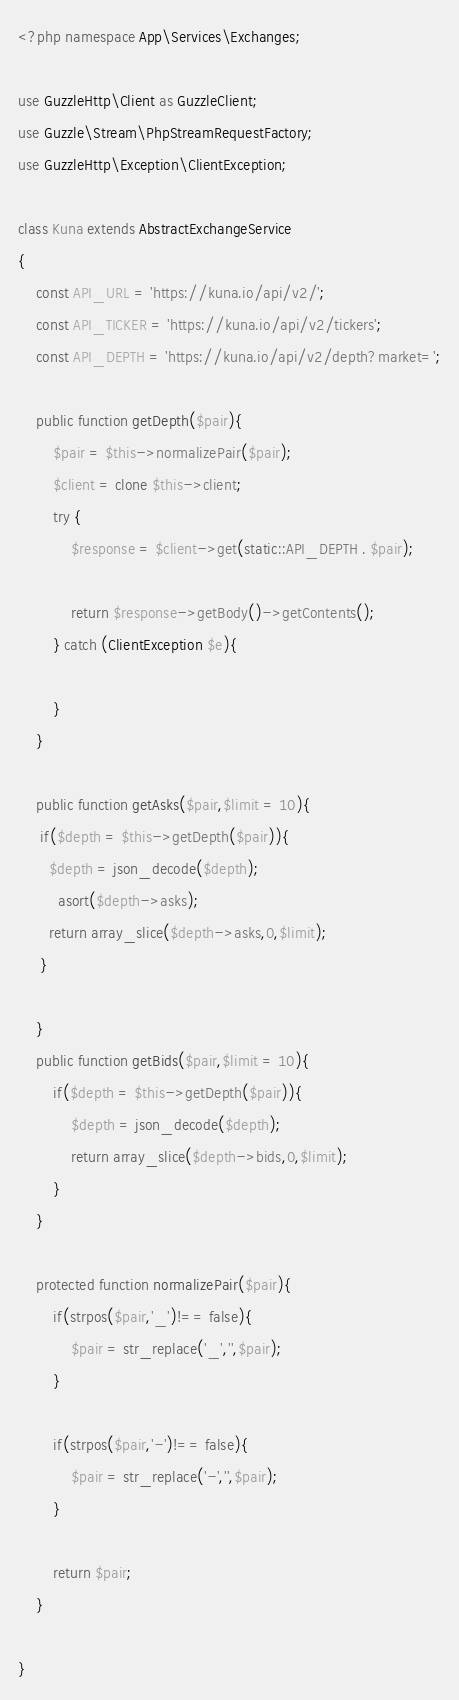Convert code to text. <code><loc_0><loc_0><loc_500><loc_500><_PHP_><?php namespace App\Services\Exchanges;

use GuzzleHttp\Client as GuzzleClient;
use Guzzle\Stream\PhpStreamRequestFactory;
use GuzzleHttp\Exception\ClientException;

class Kuna extends AbstractExchangeService
{
    const API_URL = 'https://kuna.io/api/v2/';
    const API_TICKER = 'https://kuna.io/api/v2/tickers';
    const API_DEPTH = 'https://kuna.io/api/v2/depth?market=';

    public function getDepth($pair){
        $pair = $this->normalizePair($pair);
        $client = clone $this->client;
        try {
            $response = $client->get(static::API_DEPTH . $pair);

            return $response->getBody()->getContents();
        } catch (ClientException $e){

        }
    }

    public function getAsks($pair,$limit = 10){
     if($depth = $this->getDepth($pair)){
       $depth = json_decode($depth);
         asort($depth->asks);
       return array_slice($depth->asks,0,$limit);
     }

    }
    public function getBids($pair,$limit = 10){
        if($depth = $this->getDepth($pair)){
            $depth = json_decode($depth);
            return array_slice($depth->bids,0,$limit);
        }
    }

    protected function normalizePair($pair){
        if(strpos($pair,'_')!== false){
            $pair = str_replace('_','',$pair);
        }

        if(strpos($pair,'-')!== false){
            $pair = str_replace('-','',$pair);
        }

        return $pair;
    }

}</code> 